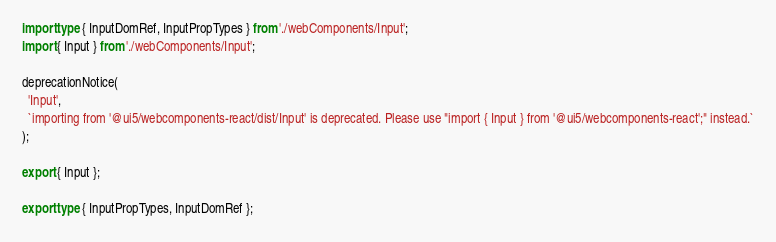<code> <loc_0><loc_0><loc_500><loc_500><_TypeScript_>import type { InputDomRef, InputPropTypes } from './webComponents/Input';
import { Input } from './webComponents/Input';

deprecationNotice(
  'Input',
  `importing from '@ui5/webcomponents-react/dist/Input' is deprecated. Please use "import { Input } from '@ui5/webcomponents-react';" instead.`
);

export { Input };

export type { InputPropTypes, InputDomRef };
</code> 